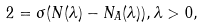Convert formula to latex. <formula><loc_0><loc_0><loc_500><loc_500>2 = \sigma ( N ( \lambda ) - N _ { A } ( \lambda ) ) , \lambda > 0 ,</formula> 